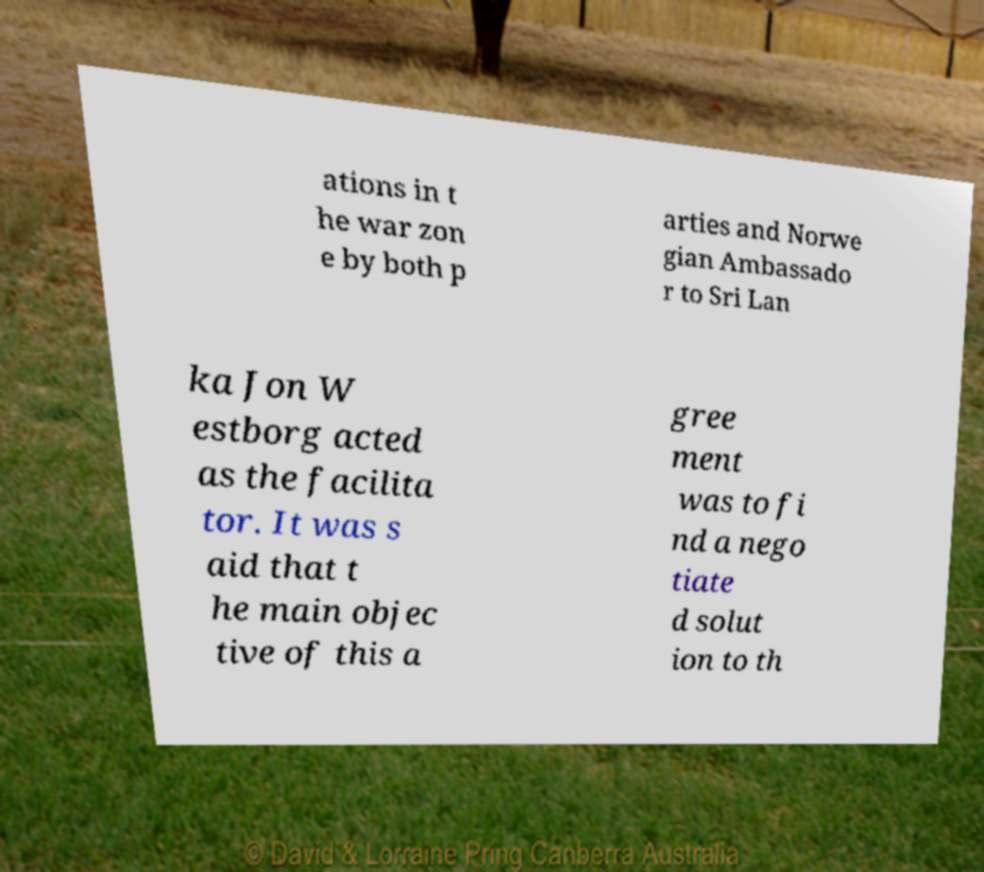What messages or text are displayed in this image? I need them in a readable, typed format. ations in t he war zon e by both p arties and Norwe gian Ambassado r to Sri Lan ka Jon W estborg acted as the facilita tor. It was s aid that t he main objec tive of this a gree ment was to fi nd a nego tiate d solut ion to th 